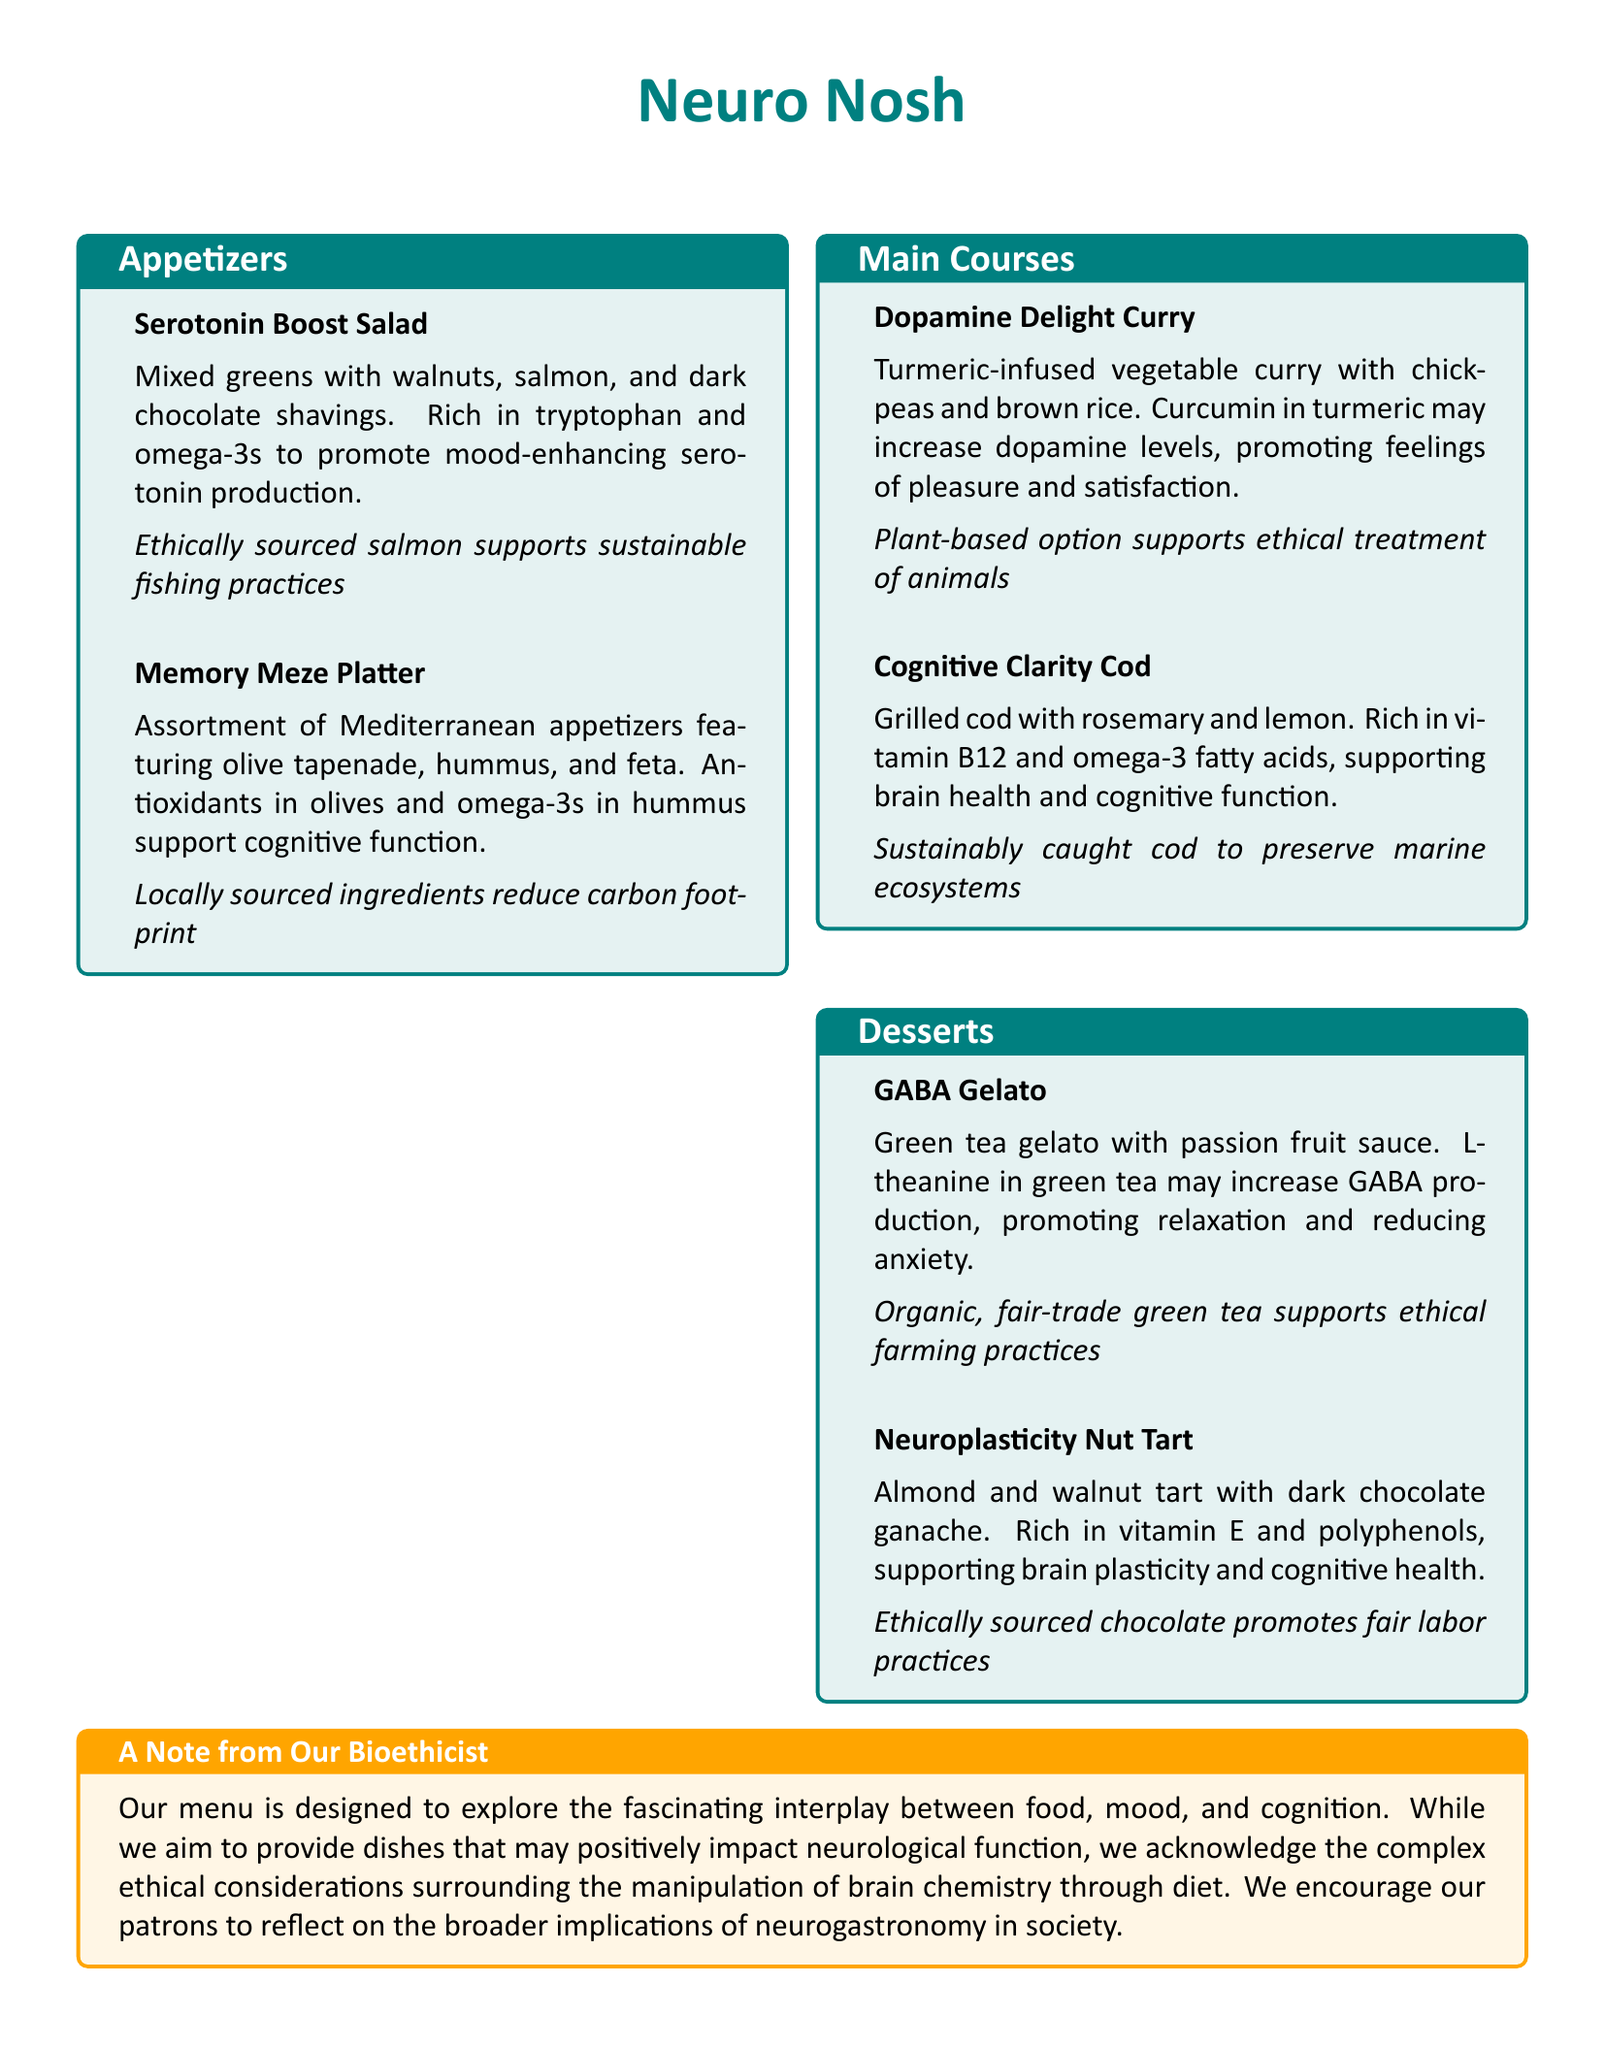What is the title of the menu? The title is prominently displayed at the top of the menu, which is "Neuro Nosh."
Answer: Neuro Nosh What dish contains walnuts? The dish featuring walnuts is the "Serotonin Boost Salad."
Answer: Serotonin Boost Salad Which dessert is made with green tea? The dessert made with green tea is called "GABA Gelato."
Answer: GABA Gelato What ingredient in the curry may increase dopamine levels? The ingredient known for potentially increasing dopamine levels in the curry is turmeric.
Answer: Turmeric How many sections are there in the menu? The menu is divided into three sections: Appetizers, Main Courses, and Desserts.
Answer: Three What is a key ethical consideration mentioned in the note? The note mentions the ethical considerations surrounding the manipulation of brain chemistry through diet.
Answer: Manipulation of brain chemistry Which dish is recommended for supporting cognitive function? The "Cognitive Clarity Cod" is recommended for supporting cognitive function.
Answer: Cognitive Clarity Cod What type of chocolate is used in the "Neuroplasticity Nut Tart"? The type of chocolate used in the tart is dark chocolate.
Answer: Dark chocolate What is the primary focus of the menu? The primary focus of the menu is exploring the interplay between food, mood, and cognition.
Answer: Food, mood, and cognition 